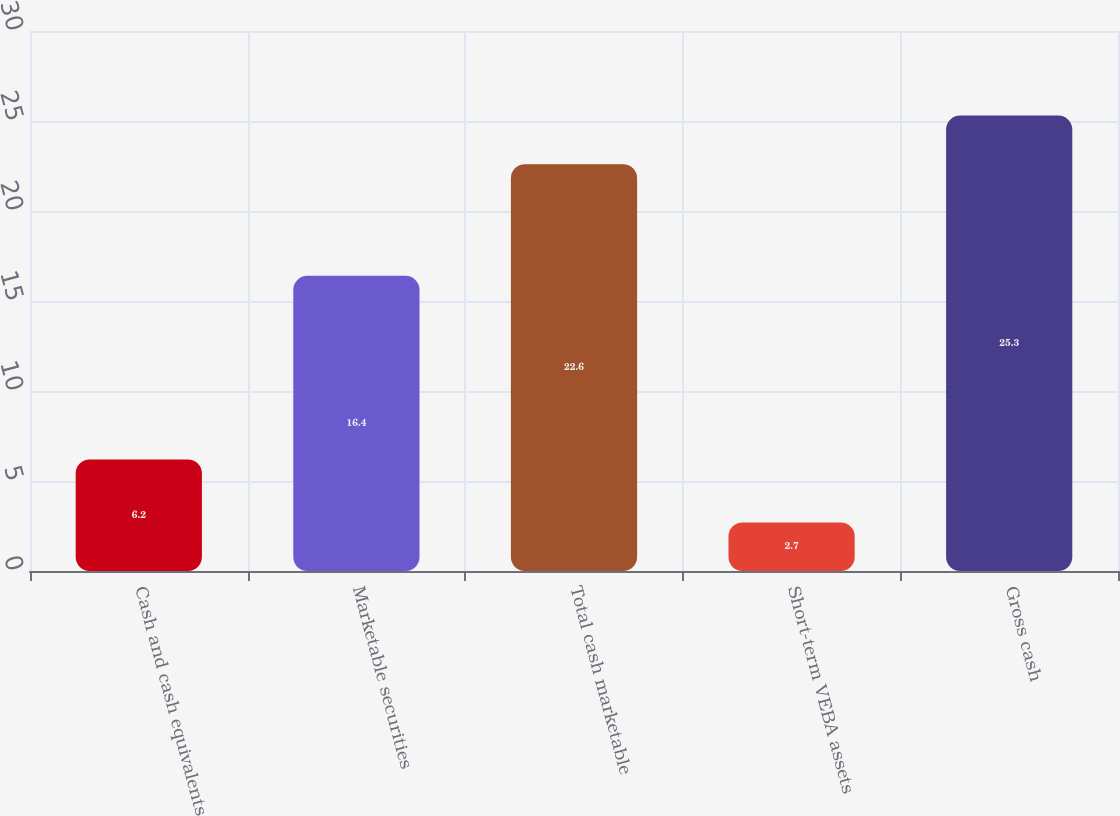<chart> <loc_0><loc_0><loc_500><loc_500><bar_chart><fcel>Cash and cash equivalents<fcel>Marketable securities<fcel>Total cash marketable<fcel>Short-term VEBA assets<fcel>Gross cash<nl><fcel>6.2<fcel>16.4<fcel>22.6<fcel>2.7<fcel>25.3<nl></chart> 